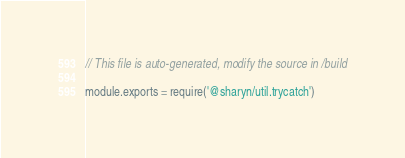Convert code to text. <code><loc_0><loc_0><loc_500><loc_500><_JavaScript_>// This file is auto-generated, modify the source in /build

module.exports = require('@sharyn/util.trycatch')
</code> 